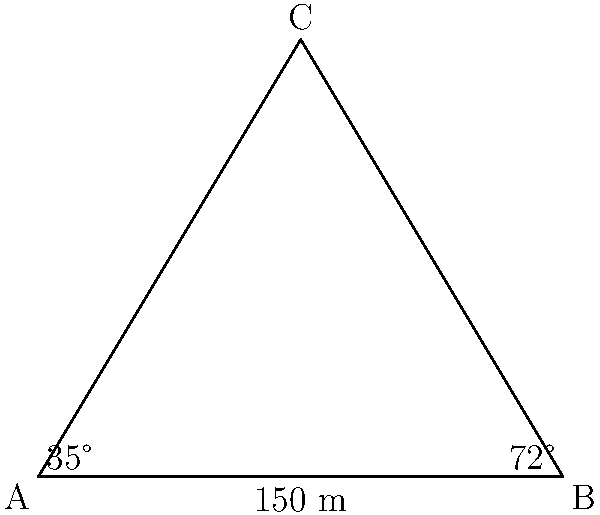A triangular field has sides AB, BC, and CA. Side AB measures 150 meters, and the angles at A and B are 35° and 72° respectively. Using the law of sines, calculate the length of side BC to the nearest meter. Let's solve this problem step-by-step using the law of sines:

1) First, recall the law of sines: 
   $$\frac{a}{\sin A} = \frac{b}{\sin B} = \frac{c}{\sin C}$$
   where $a$, $b$, and $c$ are the lengths of the sides opposite to angles $A$, $B$, and $C$ respectively.

2) We know:
   - Side $c$ (AB) = 150 m
   - Angle $A$ = 35°
   - Angle $B$ = 72°

3) We need to find side $a$ (BC). Let's set up the equation:
   $$\frac{a}{\sin 72°} = \frac{150}{\sin 35°}$$

4) Solve for $a$:
   $$a = \frac{150 \sin 72°}{\sin 35°}$$

5) Calculate:
   $$a = \frac{150 \times 0.9511}{0.5736} \approx 248.9$$

6) Rounding to the nearest meter:
   $a \approx 249$ meters
Answer: 249 meters 